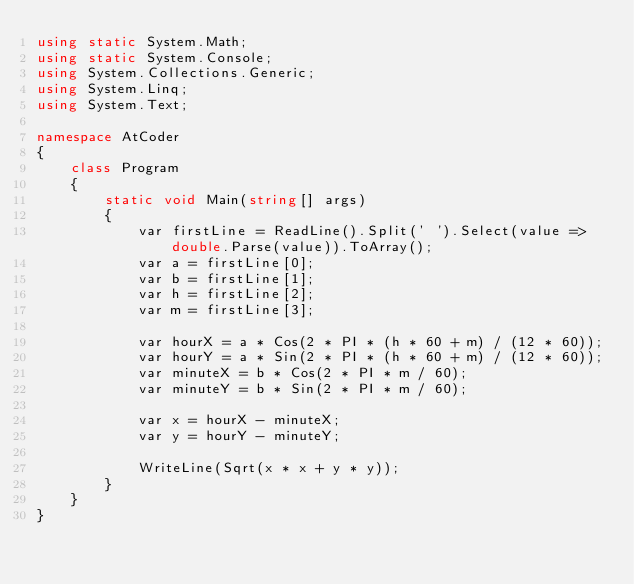Convert code to text. <code><loc_0><loc_0><loc_500><loc_500><_C#_>using static System.Math;
using static System.Console;
using System.Collections.Generic;
using System.Linq;
using System.Text;

namespace AtCoder
{
    class Program
    {
        static void Main(string[] args)
        {
            var firstLine = ReadLine().Split(' ').Select(value => double.Parse(value)).ToArray();
            var a = firstLine[0];
            var b = firstLine[1];
            var h = firstLine[2];
            var m = firstLine[3];

            var hourX = a * Cos(2 * PI * (h * 60 + m) / (12 * 60));
            var hourY = a * Sin(2 * PI * (h * 60 + m) / (12 * 60));
            var minuteX = b * Cos(2 * PI * m / 60);
            var minuteY = b * Sin(2 * PI * m / 60);

            var x = hourX - minuteX;
            var y = hourY - minuteY;

            WriteLine(Sqrt(x * x + y * y));
        }
    }
}
</code> 